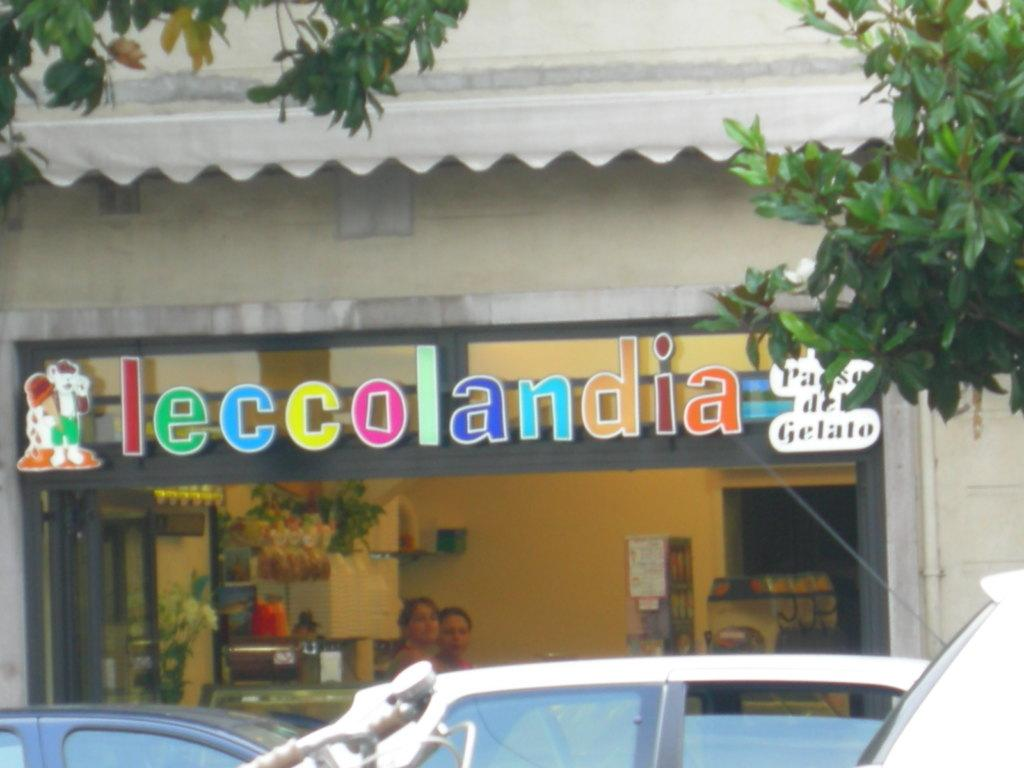What type of view is shown in the image? The image is an outside view. What can be seen in the foreground of the image? There are cars in front of a building. What is visible in the top right corner of the image? There are branches in the top right of the image. What is present in the top left corner of the image? There are branches in the top left of the image. How does the memory of the building increase in the image? There is no indication of memory in the image, as it is a static photograph. --- Facts: 1. There is a person sitting on a bench. 2. The person is reading a book. 3. There is a tree behind the bench. 4. The sky is visible in the image. Absurd Topics: parrot, dance, ocean Conversation: What is the person in the image doing? The person is sitting on a bench. What activity is the person engaged in while sitting on the bench? The person is reading a book. What can be seen behind the bench in the image? There is a tree behind the bench. What is visible in the background of the image? The sky is visible in the image. Reasoning: Let's think step by step in order to produce the conversation. We start by identifying the main subject in the image, which is the person sitting on the bench. Then, we expand the conversation to include the person's activity, which is reading a book. Next, we describe the background of the image, noting the presence of a tree and the sky. Absurd Question/Answer: Can you see a parrot dancing near the ocean in the image? No, there is no parrot or ocean present in the image. 